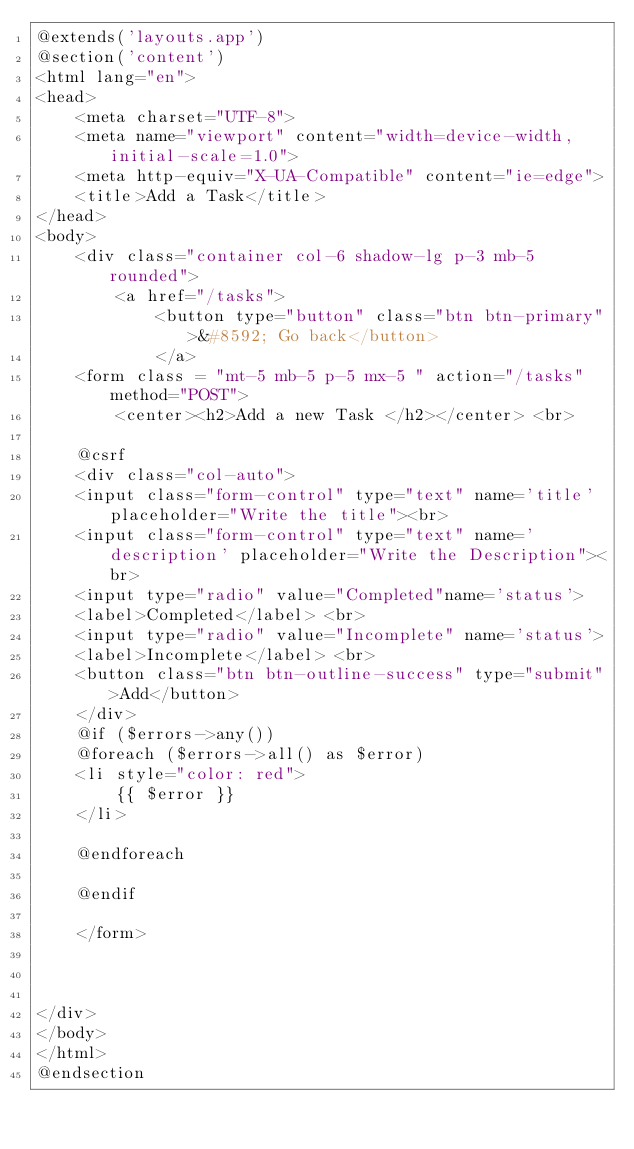Convert code to text. <code><loc_0><loc_0><loc_500><loc_500><_PHP_>@extends('layouts.app')
@section('content')
<html lang="en">
<head>
    <meta charset="UTF-8">
    <meta name="viewport" content="width=device-width, initial-scale=1.0">
    <meta http-equiv="X-UA-Compatible" content="ie=edge">
    <title>Add a Task</title>
</head>
<body>
    <div class="container col-6 shadow-lg p-3 mb-5  rounded">
        <a href="/tasks">
            <button type="button" class="btn btn-primary">&#8592; Go back</button>
            </a>
    <form class = "mt-5 mb-5 p-5 mx-5 " action="/tasks" method="POST">
        <center><h2>Add a new Task </h2></center> <br>

    @csrf
    <div class="col-auto">
    <input class="form-control" type="text" name='title' placeholder="Write the title"><br>
    <input class="form-control" type="text" name='description' placeholder="Write the Description"><br>
    <input type="radio" value="Completed"name='status'>
    <label>Completed</label> <br>
    <input type="radio" value="Incomplete" name='status'> 
    <label>Incomplete</label> <br>
    <button class="btn btn-outline-success" type="submit">Add</button>
    </div>
    @if ($errors->any())
    @foreach ($errors->all() as $error)
    <li style="color: red">
        {{ $error }}
    </li>
        
    @endforeach
        
    @endif

    </form>

  

</div>
</body>
</html>
@endsection</code> 